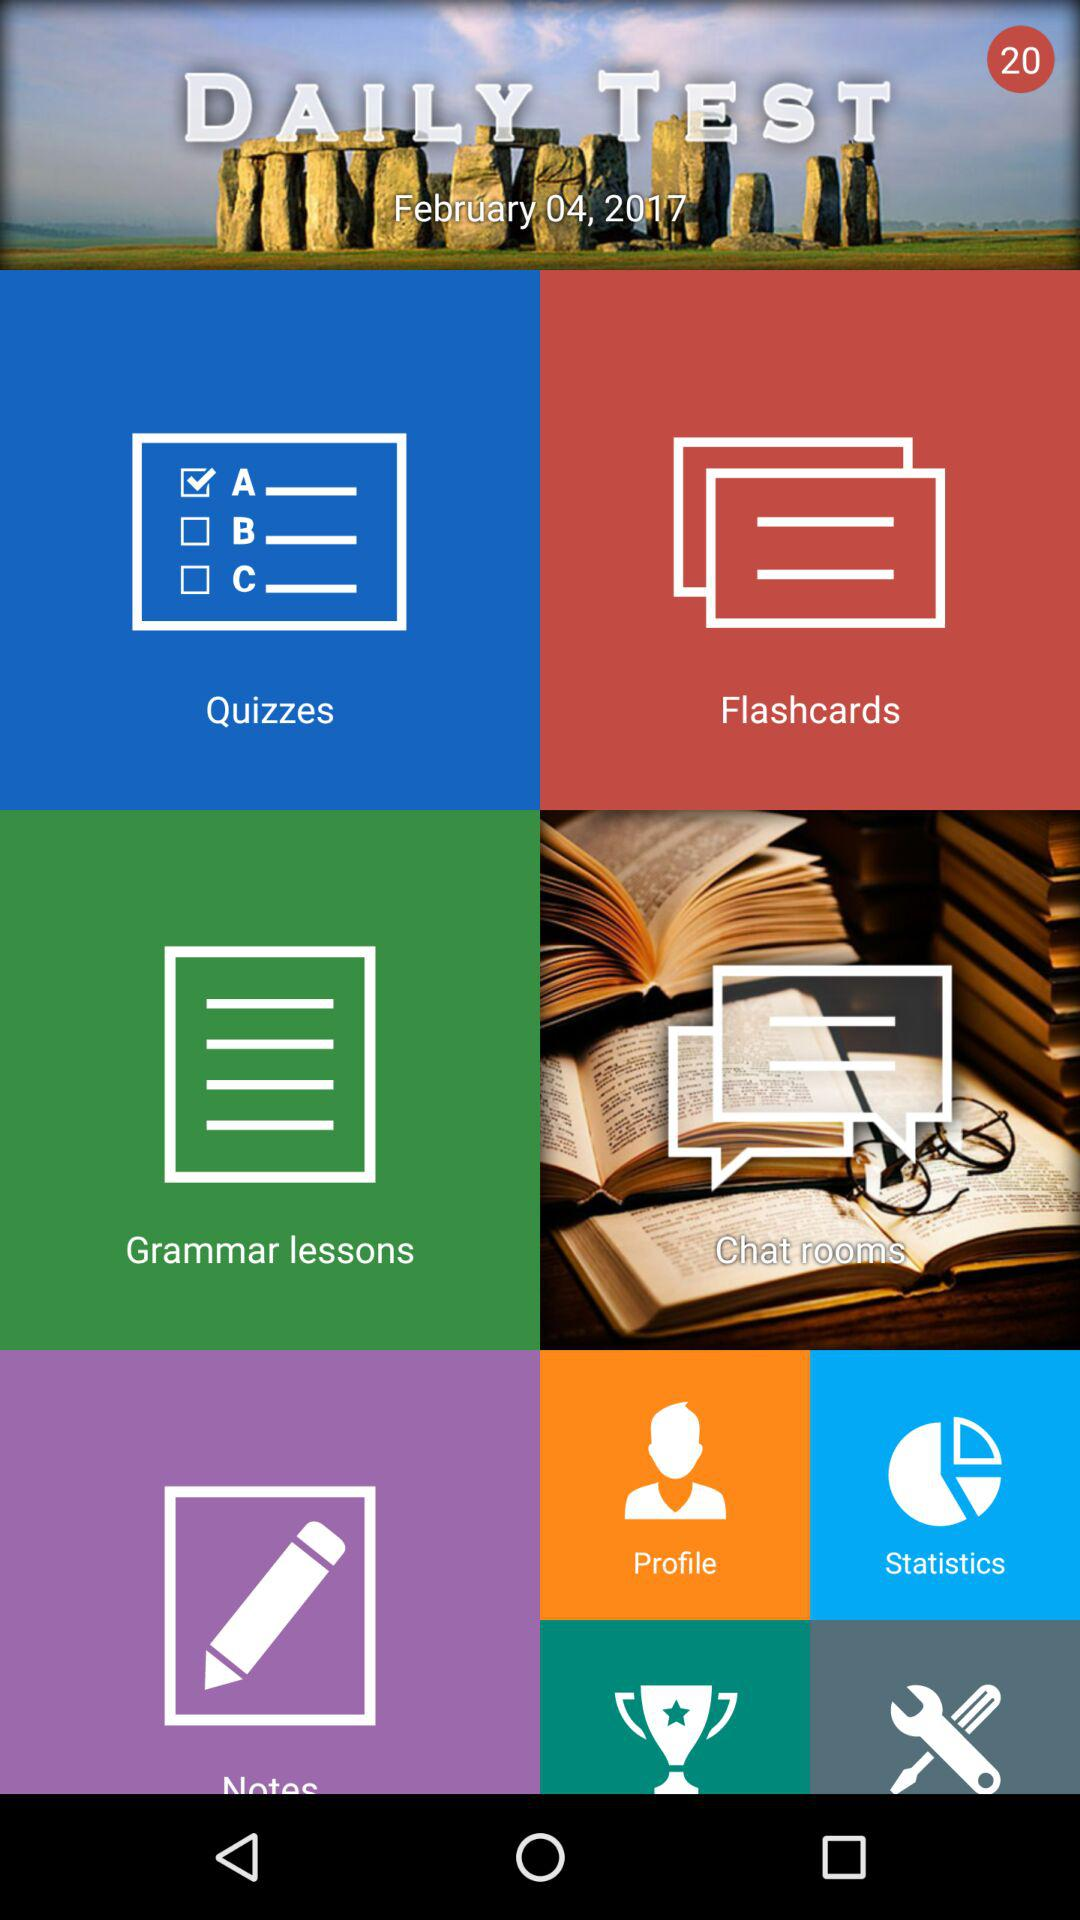What is the year given for the daily test? The given year is 2017. 